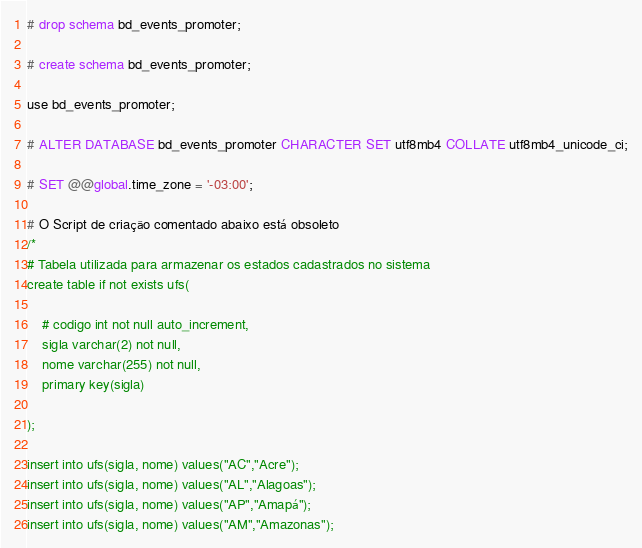Convert code to text. <code><loc_0><loc_0><loc_500><loc_500><_SQL_># drop schema bd_events_promoter;

# create schema bd_events_promoter;

use bd_events_promoter; 

# ALTER DATABASE bd_events_promoter CHARACTER SET utf8mb4 COLLATE utf8mb4_unicode_ci;

# SET @@global.time_zone = '-03:00';

# O Script de criação comentado abaixo está obsoleto
/*
# Tabela utilizada para armazenar os estados cadastrados no sistema
create table if not exists ufs(

    # codigo int not null auto_increment,
    sigla varchar(2) not null,
    nome varchar(255) not null,
    primary key(sigla) 
    
);

insert into ufs(sigla, nome) values("AC","Acre");
insert into ufs(sigla, nome) values("AL","Alagoas");
insert into ufs(sigla, nome) values("AP","Amapá");
insert into ufs(sigla, nome) values("AM","Amazonas");</code> 